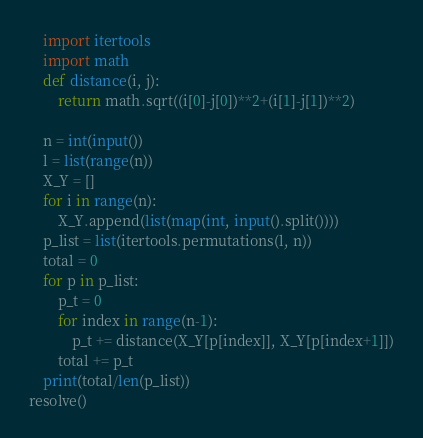Convert code to text. <code><loc_0><loc_0><loc_500><loc_500><_Python_>    import itertools
    import math
    def distance(i, j):
        return math.sqrt((i[0]-j[0])**2+(i[1]-j[1])**2)

    n = int(input())
    l = list(range(n))
    X_Y = []
    for i in range(n):
        X_Y.append(list(map(int, input().split())))
    p_list = list(itertools.permutations(l, n))
    total = 0
    for p in p_list:
        p_t = 0
        for index in range(n-1):
            p_t += distance(X_Y[p[index]], X_Y[p[index+1]])
        total += p_t
    print(total/len(p_list))
resolve()</code> 